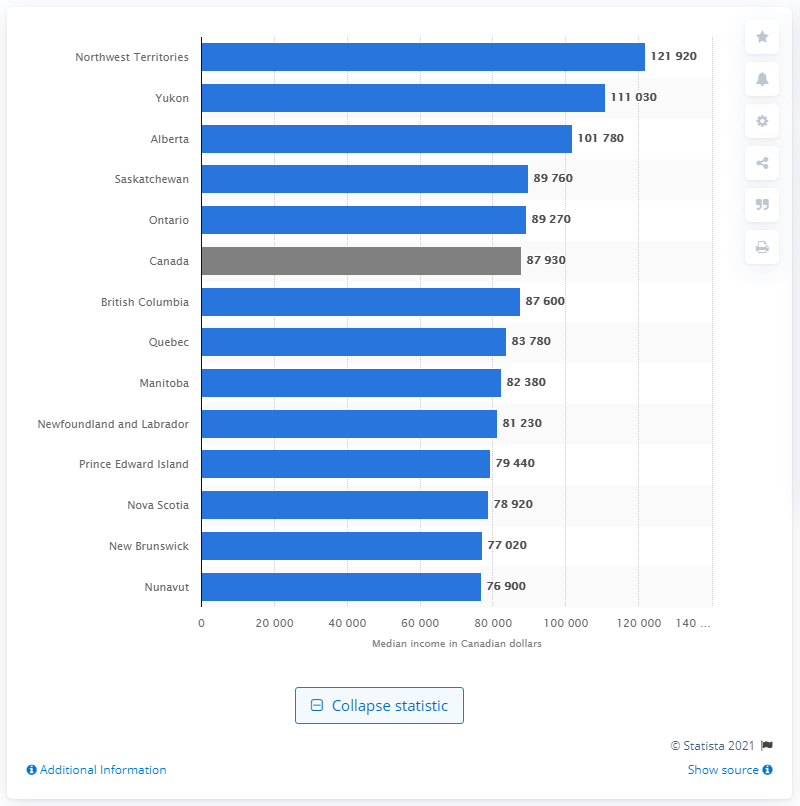Give some essential details in this illustration. The median annual family income is located in Canada. 